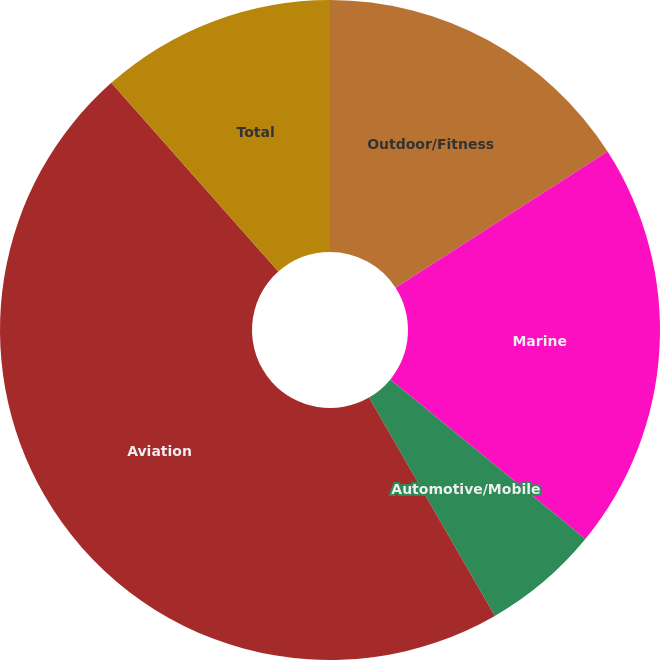Convert chart to OTSL. <chart><loc_0><loc_0><loc_500><loc_500><pie_chart><fcel>Outdoor/Fitness<fcel>Marine<fcel>Automotive/Mobile<fcel>Aviation<fcel>Total<nl><fcel>15.91%<fcel>20.01%<fcel>5.76%<fcel>46.8%<fcel>11.53%<nl></chart> 